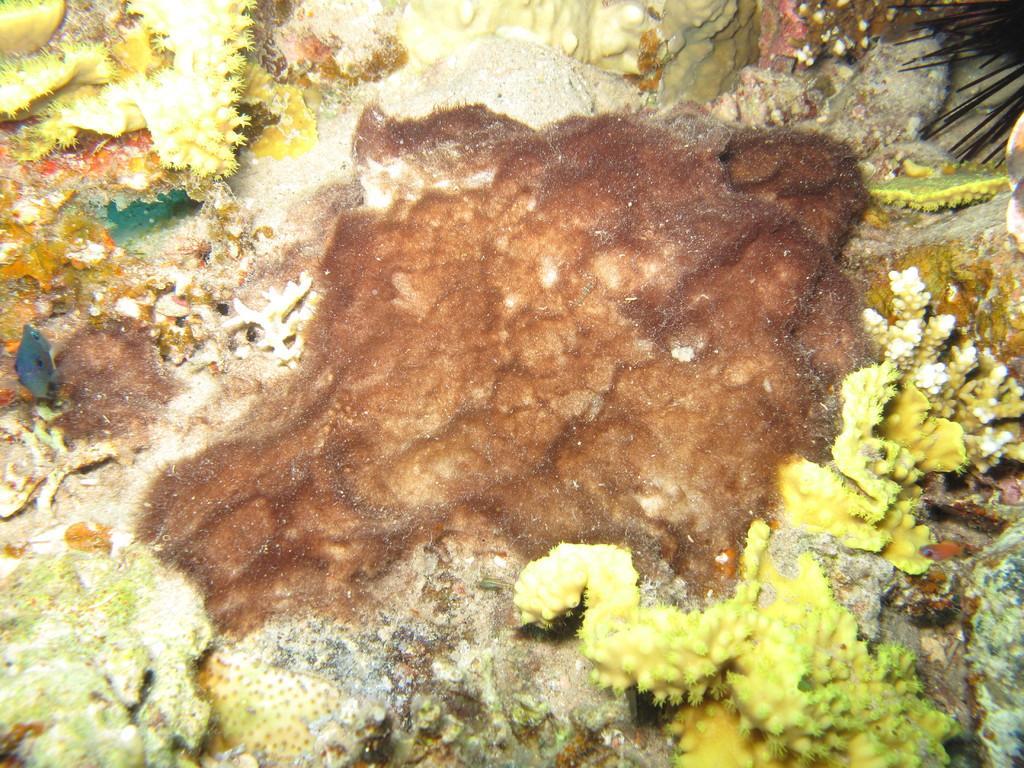How would you summarize this image in a sentence or two? In this image I can see few plants. I can also see a brown colour patch in the centre of this image. 